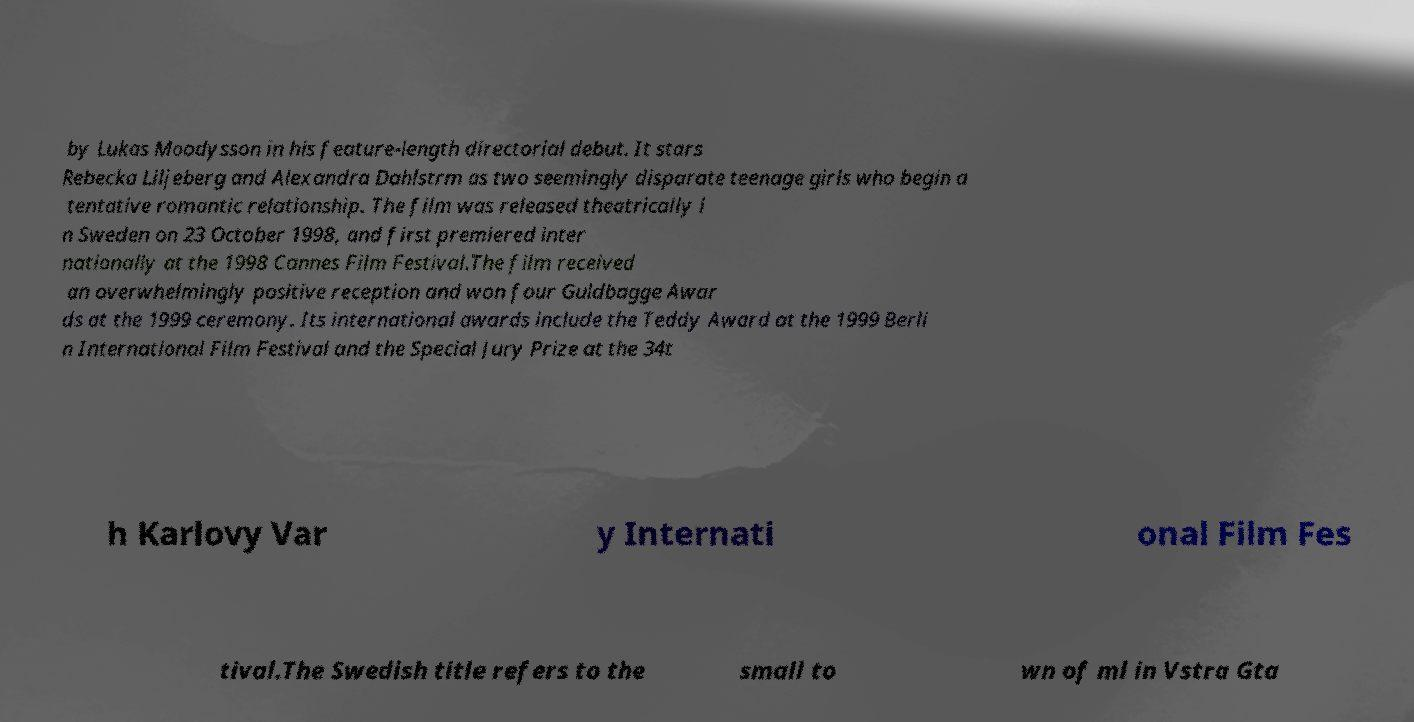There's text embedded in this image that I need extracted. Can you transcribe it verbatim? by Lukas Moodysson in his feature-length directorial debut. It stars Rebecka Liljeberg and Alexandra Dahlstrm as two seemingly disparate teenage girls who begin a tentative romantic relationship. The film was released theatrically i n Sweden on 23 October 1998, and first premiered inter nationally at the 1998 Cannes Film Festival.The film received an overwhelmingly positive reception and won four Guldbagge Awar ds at the 1999 ceremony. Its international awards include the Teddy Award at the 1999 Berli n International Film Festival and the Special Jury Prize at the 34t h Karlovy Var y Internati onal Film Fes tival.The Swedish title refers to the small to wn of ml in Vstra Gta 